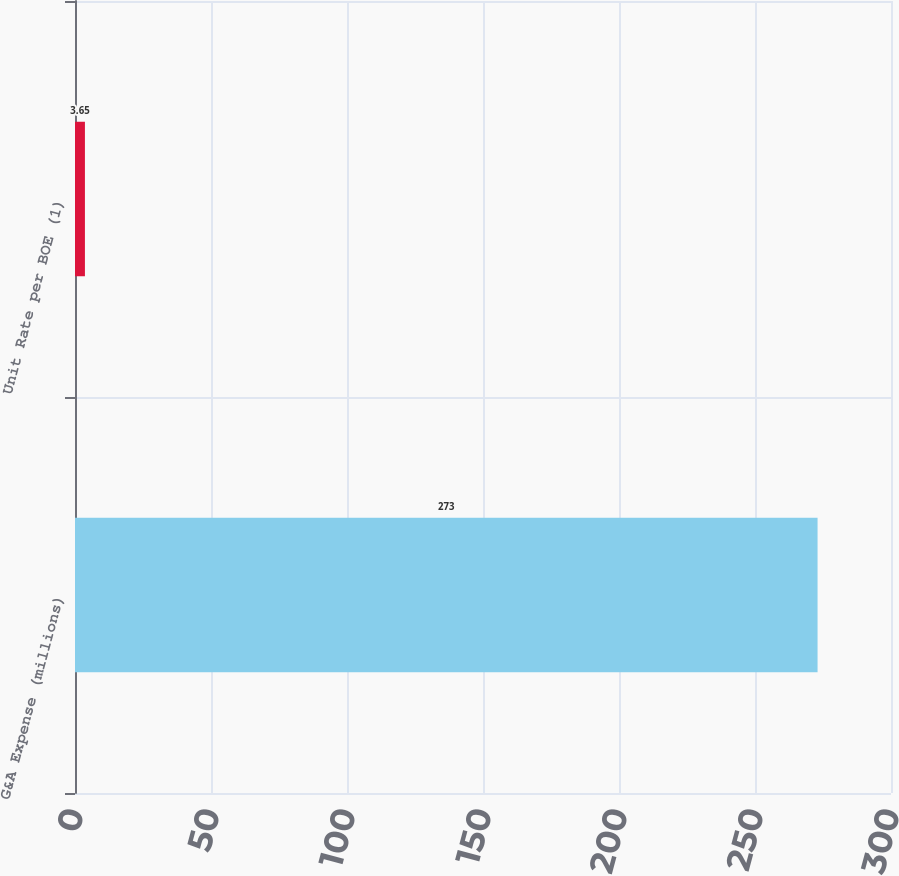<chart> <loc_0><loc_0><loc_500><loc_500><bar_chart><fcel>G&A Expense (millions)<fcel>Unit Rate per BOE (1)<nl><fcel>273<fcel>3.65<nl></chart> 